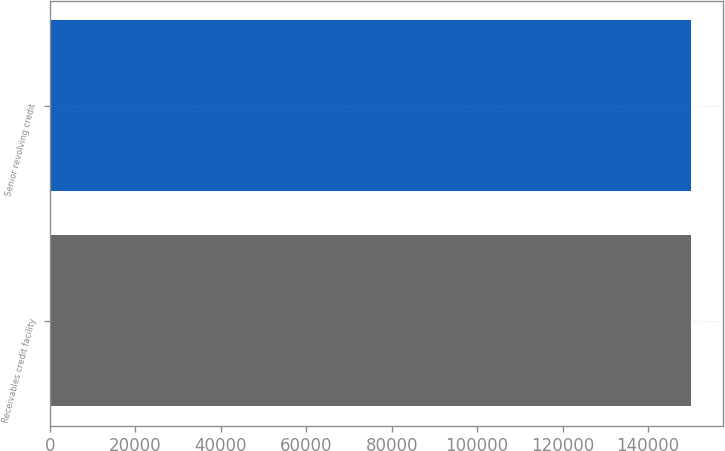Convert chart. <chart><loc_0><loc_0><loc_500><loc_500><bar_chart><fcel>Receivables credit facility<fcel>Senior revolving credit<nl><fcel>150000<fcel>150000<nl></chart> 